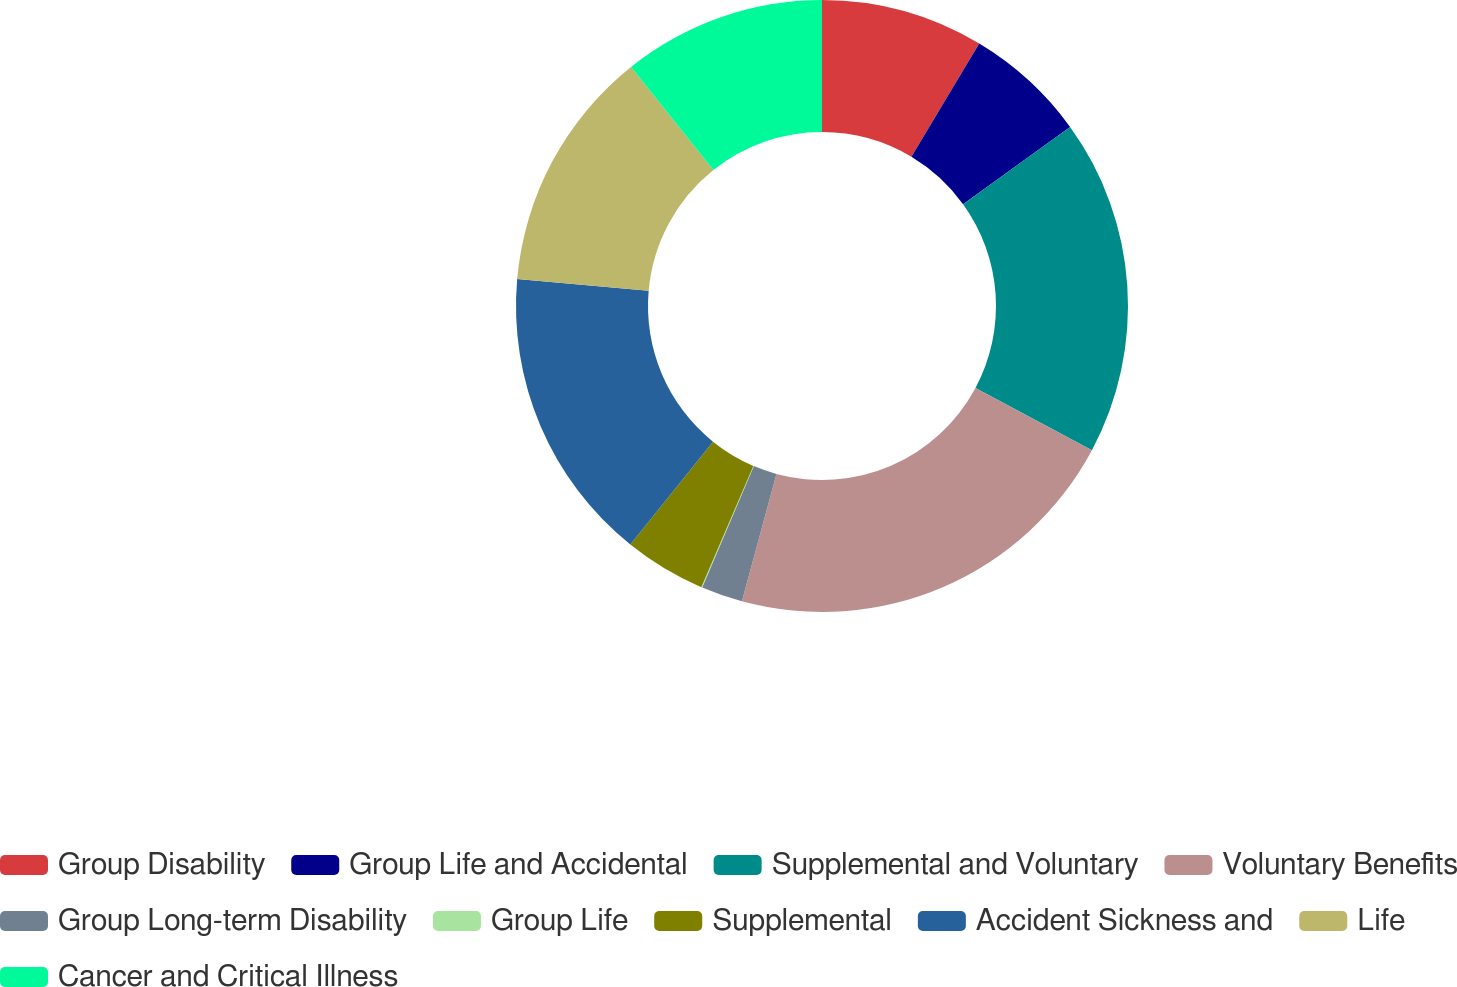Convert chart to OTSL. <chart><loc_0><loc_0><loc_500><loc_500><pie_chart><fcel>Group Disability<fcel>Group Life and Accidental<fcel>Supplemental and Voluntary<fcel>Voluntary Benefits<fcel>Group Long-term Disability<fcel>Group Life<fcel>Supplemental<fcel>Accident Sickness and<fcel>Life<fcel>Cancer and Critical Illness<nl><fcel>8.59%<fcel>6.46%<fcel>17.76%<fcel>21.41%<fcel>2.19%<fcel>0.05%<fcel>4.32%<fcel>15.63%<fcel>12.87%<fcel>10.73%<nl></chart> 